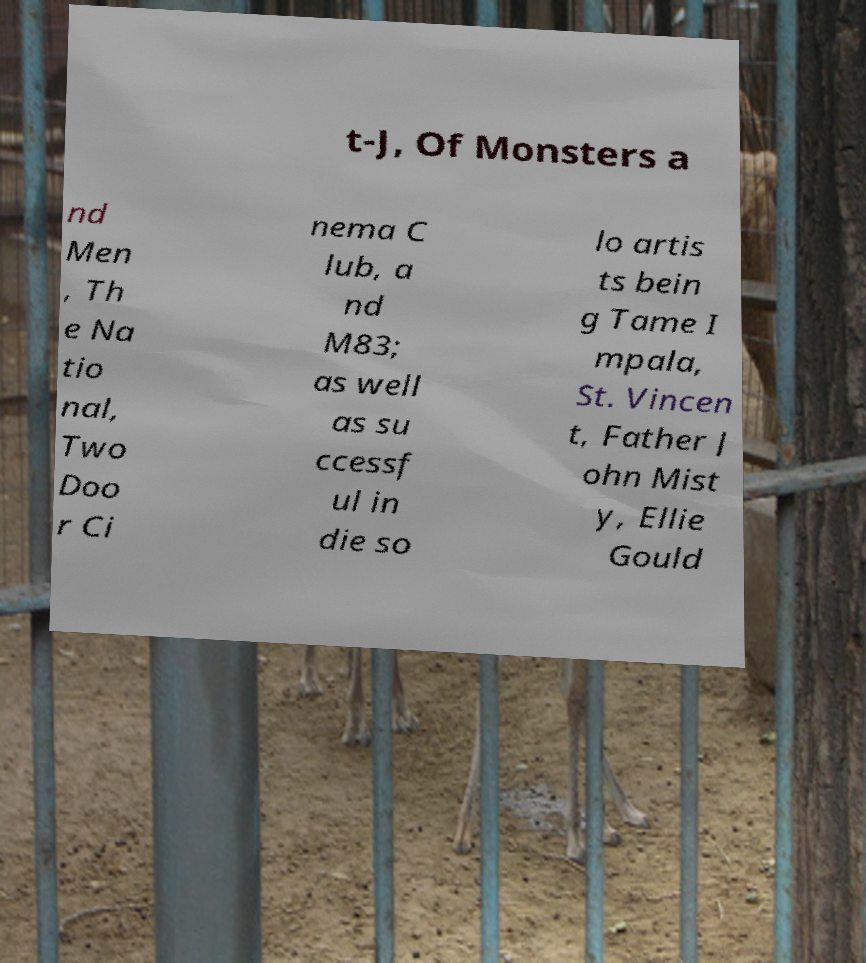Please identify and transcribe the text found in this image. t-J, Of Monsters a nd Men , Th e Na tio nal, Two Doo r Ci nema C lub, a nd M83; as well as su ccessf ul in die so lo artis ts bein g Tame I mpala, St. Vincen t, Father J ohn Mist y, Ellie Gould 